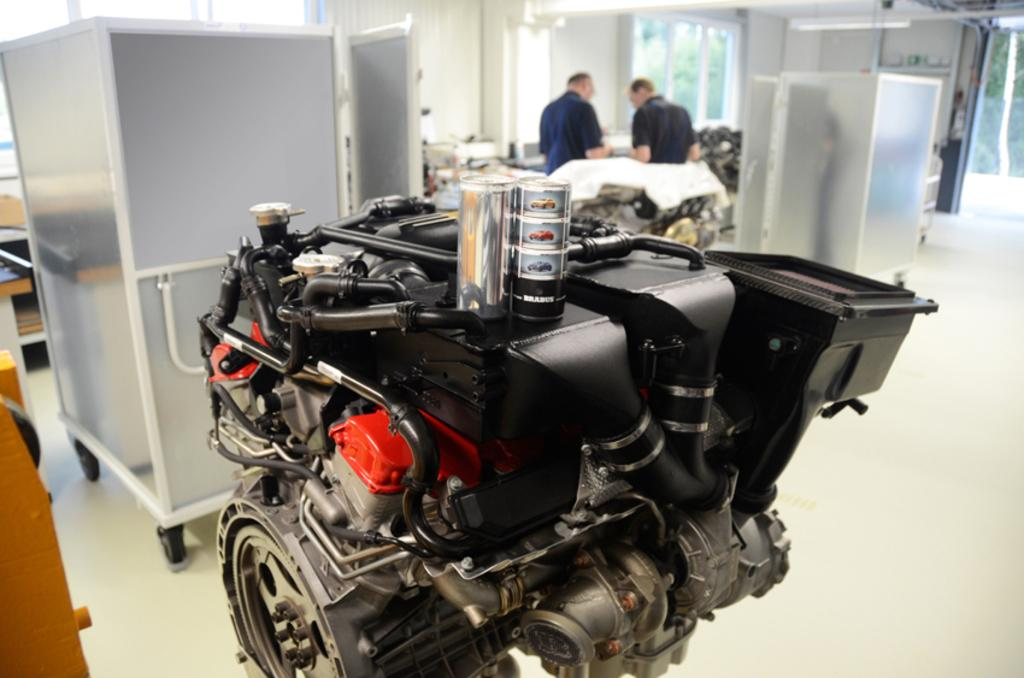How many people are present in the image? There are two persons standing in the image. What can be seen besides the people in the image? There are electrical machines in the image. What type of natural scenery is visible in the background? There are trees in the background of the image. What type of death can be seen in the image? There is no death present in the image; it features two people and electrical machines. How many people are joining the group in the image? There is no indication of people joining the group in the image, as it only shows two people. 